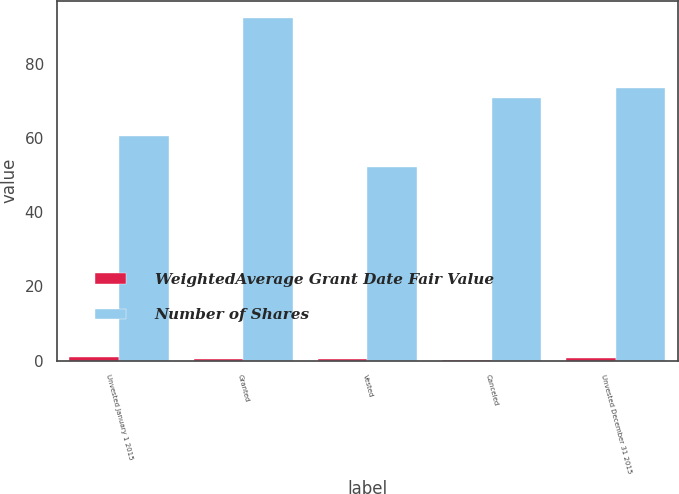Convert chart to OTSL. <chart><loc_0><loc_0><loc_500><loc_500><stacked_bar_chart><ecel><fcel>Unvested January 1 2015<fcel>Granted<fcel>Vested<fcel>Canceled<fcel>Unvested December 31 2015<nl><fcel>WeightedAverage Grant Date Fair Value<fcel>1<fcel>0.3<fcel>0.4<fcel>0.1<fcel>0.8<nl><fcel>Number of Shares<fcel>60.68<fcel>92.44<fcel>52.11<fcel>70.96<fcel>73.58<nl></chart> 